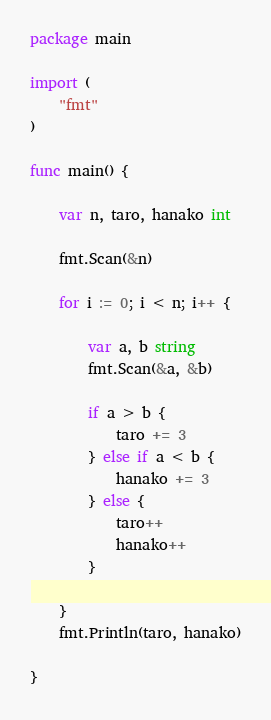Convert code to text. <code><loc_0><loc_0><loc_500><loc_500><_Go_>package main

import (
	"fmt"
)

func main() {

	var n, taro, hanako int

	fmt.Scan(&n)

	for i := 0; i < n; i++ {

		var a, b string
		fmt.Scan(&a, &b)

		if a > b {
			taro += 3
		} else if a < b {
			hanako += 3
		} else {
			taro++
			hanako++
		}

	}
	fmt.Println(taro, hanako)

}

</code> 